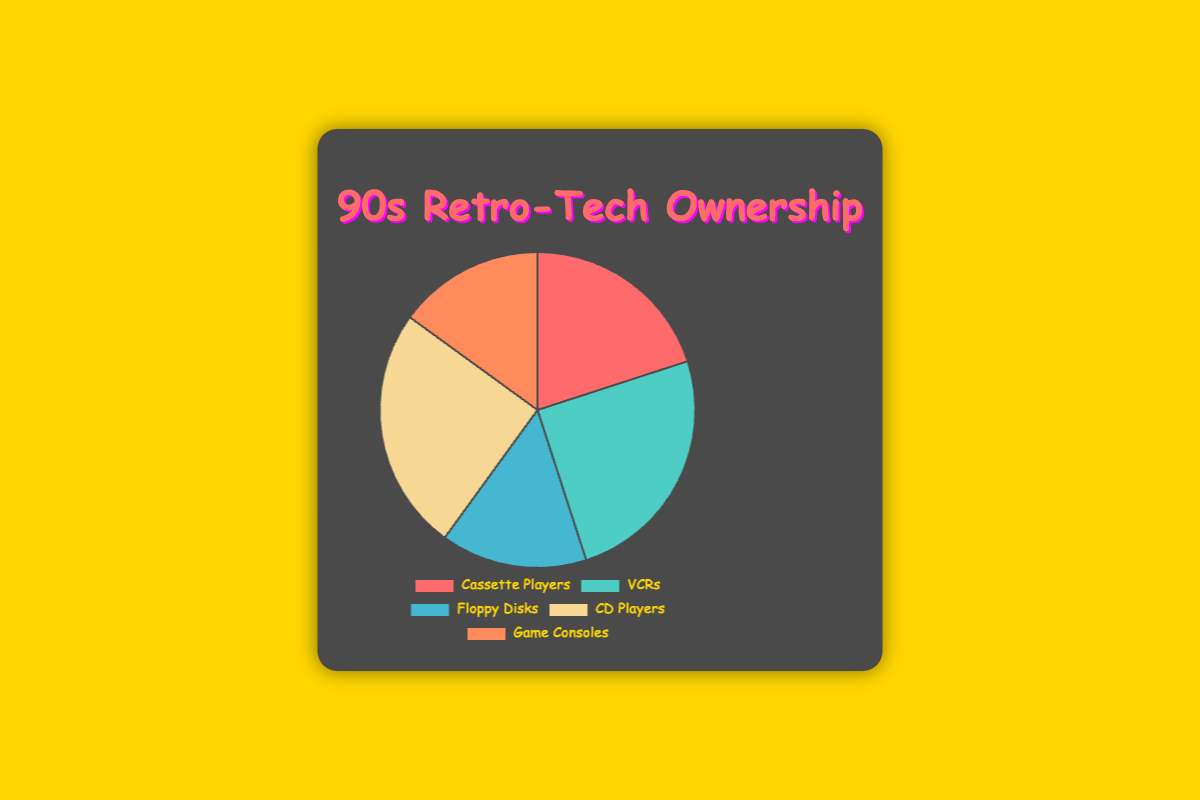What's the most common type of retro-tech owned? Looking at the figure, the largest segments correspond to VCRs and CD Players, each with 25%. Therefore, the most common types are VCRs and CD Players.
Answer: VCRs, CD Players Which type has the smallest percentage of ownership? The smallest segments in the pie chart are Floppy Disks and Game Consoles, both at 15%. Therefore, these are the types with the smallest ownership.
Answer: Floppy Disks, Game Consoles How does the ownership of Cassette Players compare to CD Players? Cassette Players have a 20% ownership share, whereas CD Players have a 25% share. Comparing these two, CD Players have a higher percentage of ownership.
Answer: CD Players have more What is the combined percentage of ownership for Floppy Disks and Game Consoles? Adding the percentages of Floppy Disks (15%) and Game Consoles (15%), we get a combined ownership of 15% + 15% = 30%.
Answer: 30% If we exclude CD Players, what is the total percentage of the remaining types? Excluding CD Players (25%), we sum up the other percentages: Cassette Players (20%) + VCRs (25%) + Floppy Disks (15%) + Game Consoles (15%). The total is 20% + 25% + 15% + 15% = 75%.
Answer: 75% What type of retro-tech is represented by the red segment? The colors in the pie chart are associated with specific data points. The red segment corresponds to Cassette Players, which has a 20% share.
Answer: Cassette Players Is the ownership of Game Consoles greater than, less than, or equal to the ownership of VCRs? Game Consoles have a 15% ownership share, while VCRs have a 25% share. Therefore, Game Consoles have a smaller share compared to VCRs.
Answer: less than Which types of retro-tech represent a combined total closer to a quarter of the pie chart? The pie chart pieces closest to 25% are VCRs (25%) and CD Players (25%). Any combination of two other types will exceed or be under 25%. Therefore, VCRs and CD Players each represent about a quarter individually, not combined.
Answer: VCRs, CD Players How many types of retro-tech have ownership percentages greater than 20%? We identify that only two types, VCRs (25%) and CD Players (25%), have percentages greater than 20%.
Answer: 2 Which type of retro-tech owned by '90s teenagers now in their 40s has the same percentage as Cassette Players? Cassette Players hold a 20% share. No other type exactly matches this percentage, hence none share the same percentage.
Answer: none 